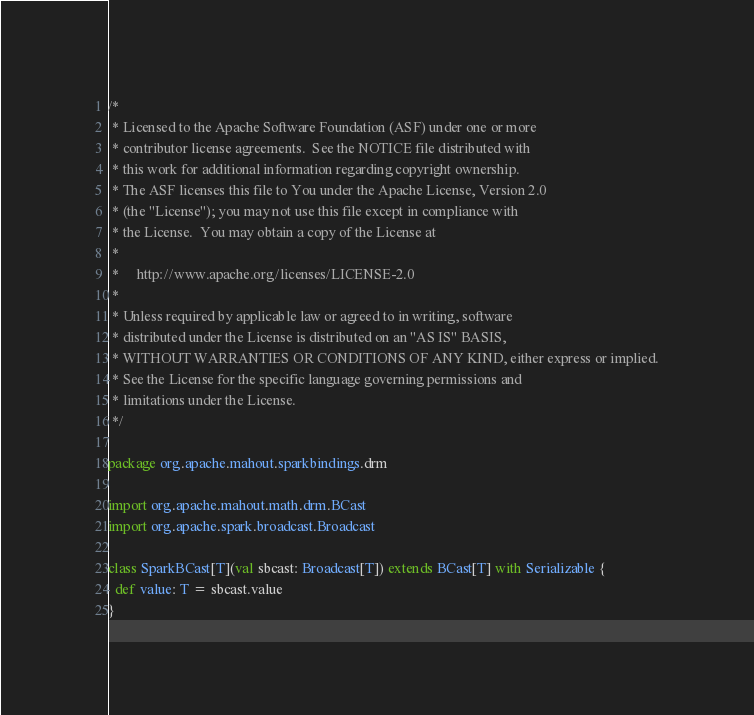Convert code to text. <code><loc_0><loc_0><loc_500><loc_500><_Scala_>/*
 * Licensed to the Apache Software Foundation (ASF) under one or more
 * contributor license agreements.  See the NOTICE file distributed with
 * this work for additional information regarding copyright ownership.
 * The ASF licenses this file to You under the Apache License, Version 2.0
 * (the "License"); you may not use this file except in compliance with
 * the License.  You may obtain a copy of the License at
 *
 *     http://www.apache.org/licenses/LICENSE-2.0
 *
 * Unless required by applicable law or agreed to in writing, software
 * distributed under the License is distributed on an "AS IS" BASIS,
 * WITHOUT WARRANTIES OR CONDITIONS OF ANY KIND, either express or implied.
 * See the License for the specific language governing permissions and
 * limitations under the License.
 */

package org.apache.mahout.sparkbindings.drm

import org.apache.mahout.math.drm.BCast
import org.apache.spark.broadcast.Broadcast

class SparkBCast[T](val sbcast: Broadcast[T]) extends BCast[T] with Serializable {
  def value: T = sbcast.value
}
</code> 